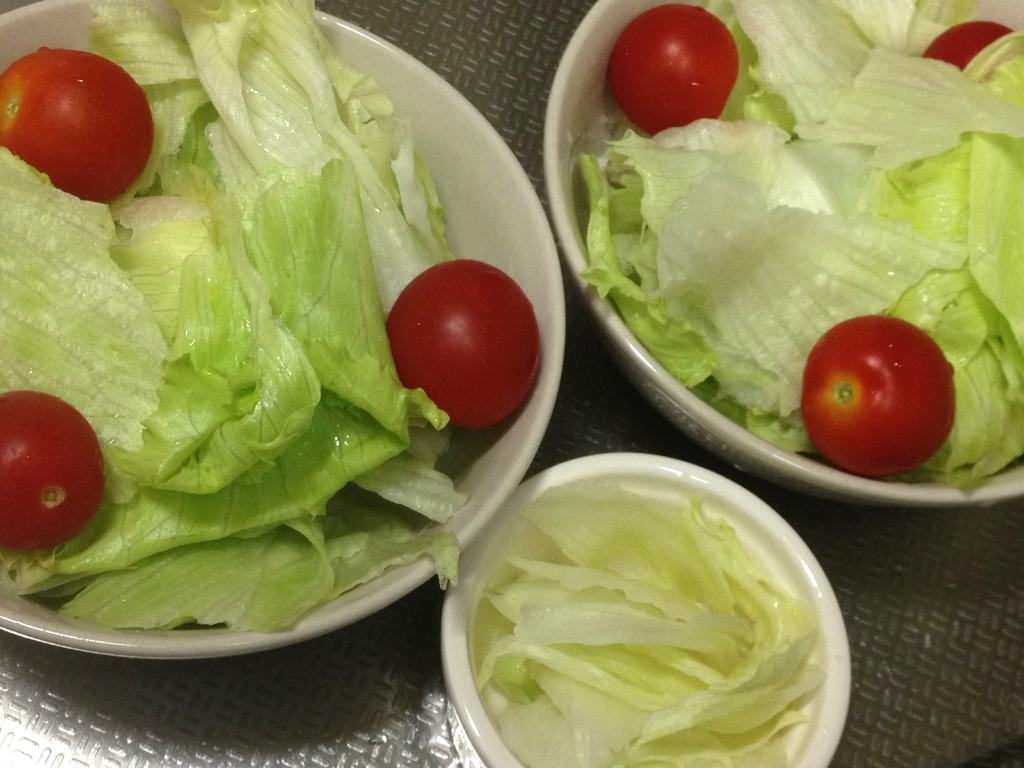What type of food is visible in the image? There are vegetables in the image. How are the vegetables arranged or presented? The vegetables are in bowls. Where are the bowls of vegetables located? The bowls are on a platform. What month is it in the image? There is no indication of a specific month in the image. 